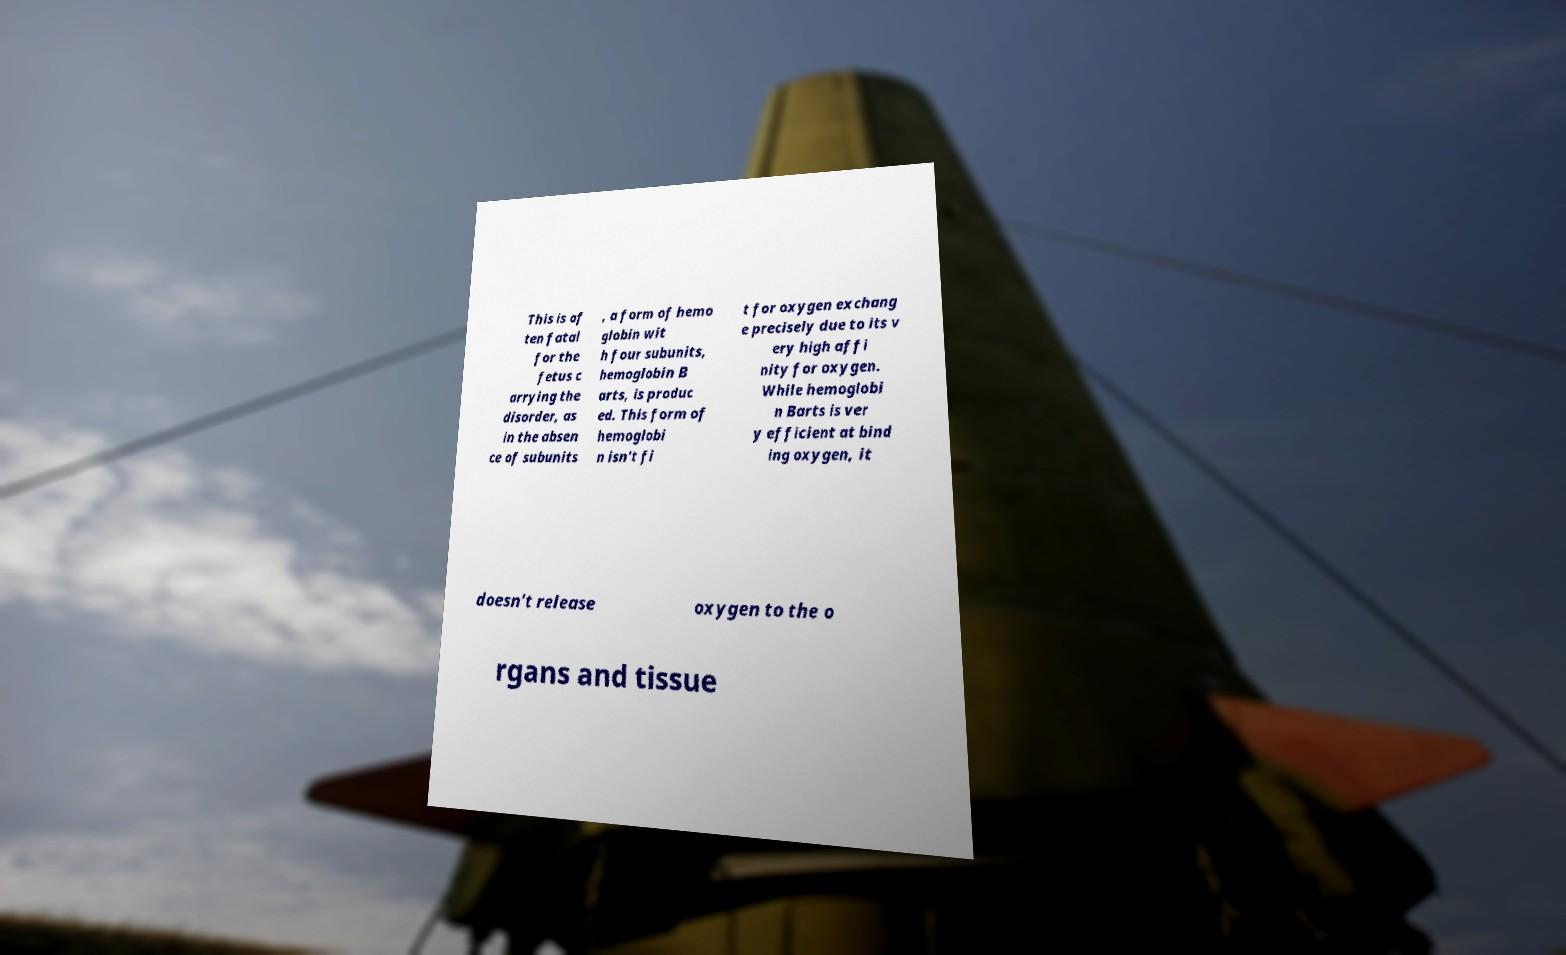I need the written content from this picture converted into text. Can you do that? This is of ten fatal for the fetus c arrying the disorder, as in the absen ce of subunits , a form of hemo globin wit h four subunits, hemoglobin B arts, is produc ed. This form of hemoglobi n isn't fi t for oxygen exchang e precisely due to its v ery high affi nity for oxygen. While hemoglobi n Barts is ver y efficient at bind ing oxygen, it doesn't release oxygen to the o rgans and tissue 